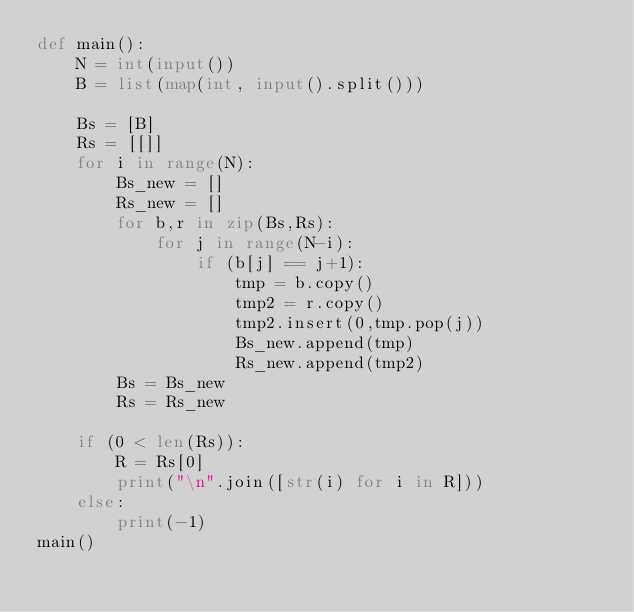<code> <loc_0><loc_0><loc_500><loc_500><_Python_>def main():
    N = int(input())
    B = list(map(int, input().split()))
    
    Bs = [B]
    Rs = [[]]
    for i in range(N):
        Bs_new = []
        Rs_new = []
        for b,r in zip(Bs,Rs):
            for j in range(N-i):
                if (b[j] == j+1):
                    tmp = b.copy()
                    tmp2 = r.copy()
                    tmp2.insert(0,tmp.pop(j))
                    Bs_new.append(tmp)
                    Rs_new.append(tmp2)
        Bs = Bs_new
        Rs = Rs_new
    
    if (0 < len(Rs)):
        R = Rs[0]
        print("\n".join([str(i) for i in R]))
    else:
        print(-1)
main()
</code> 